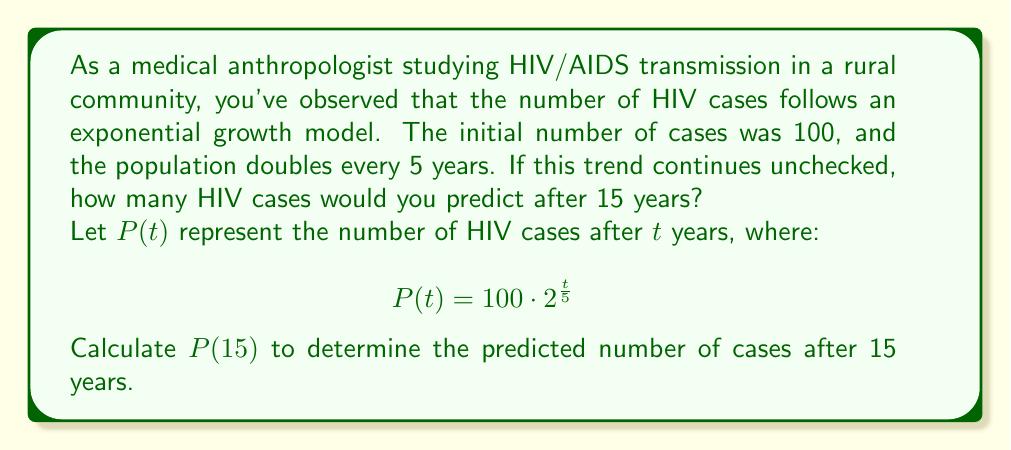Can you solve this math problem? To solve this problem, we'll use the given exponential growth model and follow these steps:

1) The general form of the equation is:
   $$P(t) = 100 \cdot 2^{\frac{t}{5}}$$

2) We need to find $P(15)$, so we substitute $t = 15$ into the equation:
   $$P(15) = 100 \cdot 2^{\frac{15}{5}}$$

3) Simplify the exponent:
   $$P(15) = 100 \cdot 2^3$$

4) Calculate $2^3$:
   $$P(15) = 100 \cdot 8$$

5) Multiply:
   $$P(15) = 800$$

Therefore, after 15 years, the model predicts 800 HIV cases in the community.
Answer: 800 cases 